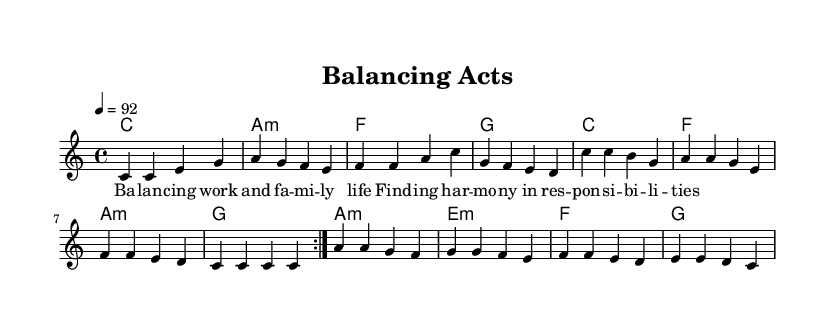What is the key signature of this music? The key signature is C major, which has no sharps or flats.
Answer: C major What is the time signature of the piece? The time signature is indicated as 4/4, which means there are four beats in each measure.
Answer: 4/4 What is the tempo marking for this music? The tempo marking is 92 beats per minute, indicated by the tempo notation of 4 = 92.
Answer: 92 How many measures are in the verse section? The verse section consists of four measures as shown in the melody, repeating twice results in eight measures.
Answer: Four What chord follows the A minor chord in the chorus? The chord that follows A minor in the chorus is G major, as seen in the chord progression.
Answer: G How many times is the melody repeated in the piece? The melody is repeated two times, as indicated by the volta markings in the score.
Answer: Two What theme is explored in the lyrics? The lyrics explore the theme of balancing work and family life, emphasizing harmony in responsibilities.
Answer: Work and family life 